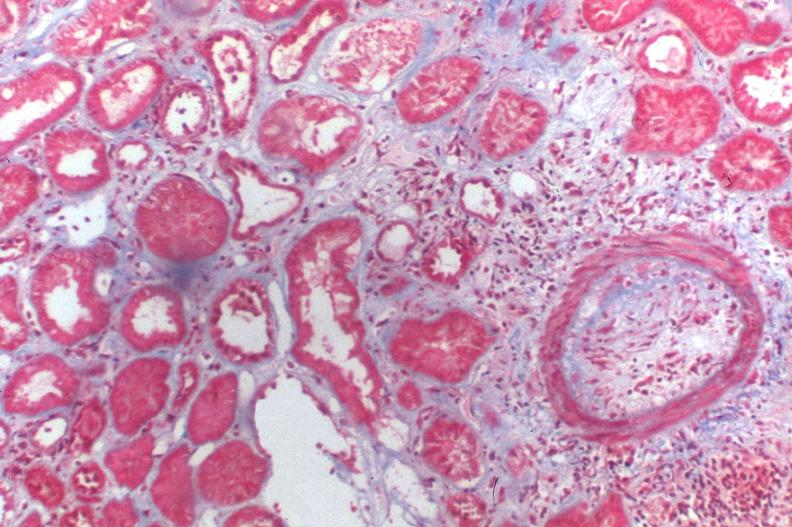what does this image show?
Answer the question using a single word or phrase. Kidney transplant rejection 